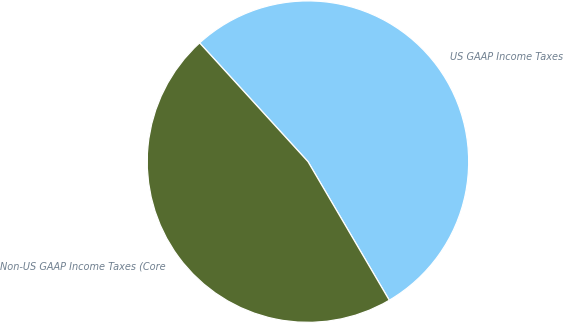Convert chart. <chart><loc_0><loc_0><loc_500><loc_500><pie_chart><fcel>US GAAP Income Taxes<fcel>Non-US GAAP Income Taxes (Core<nl><fcel>53.33%<fcel>46.67%<nl></chart> 